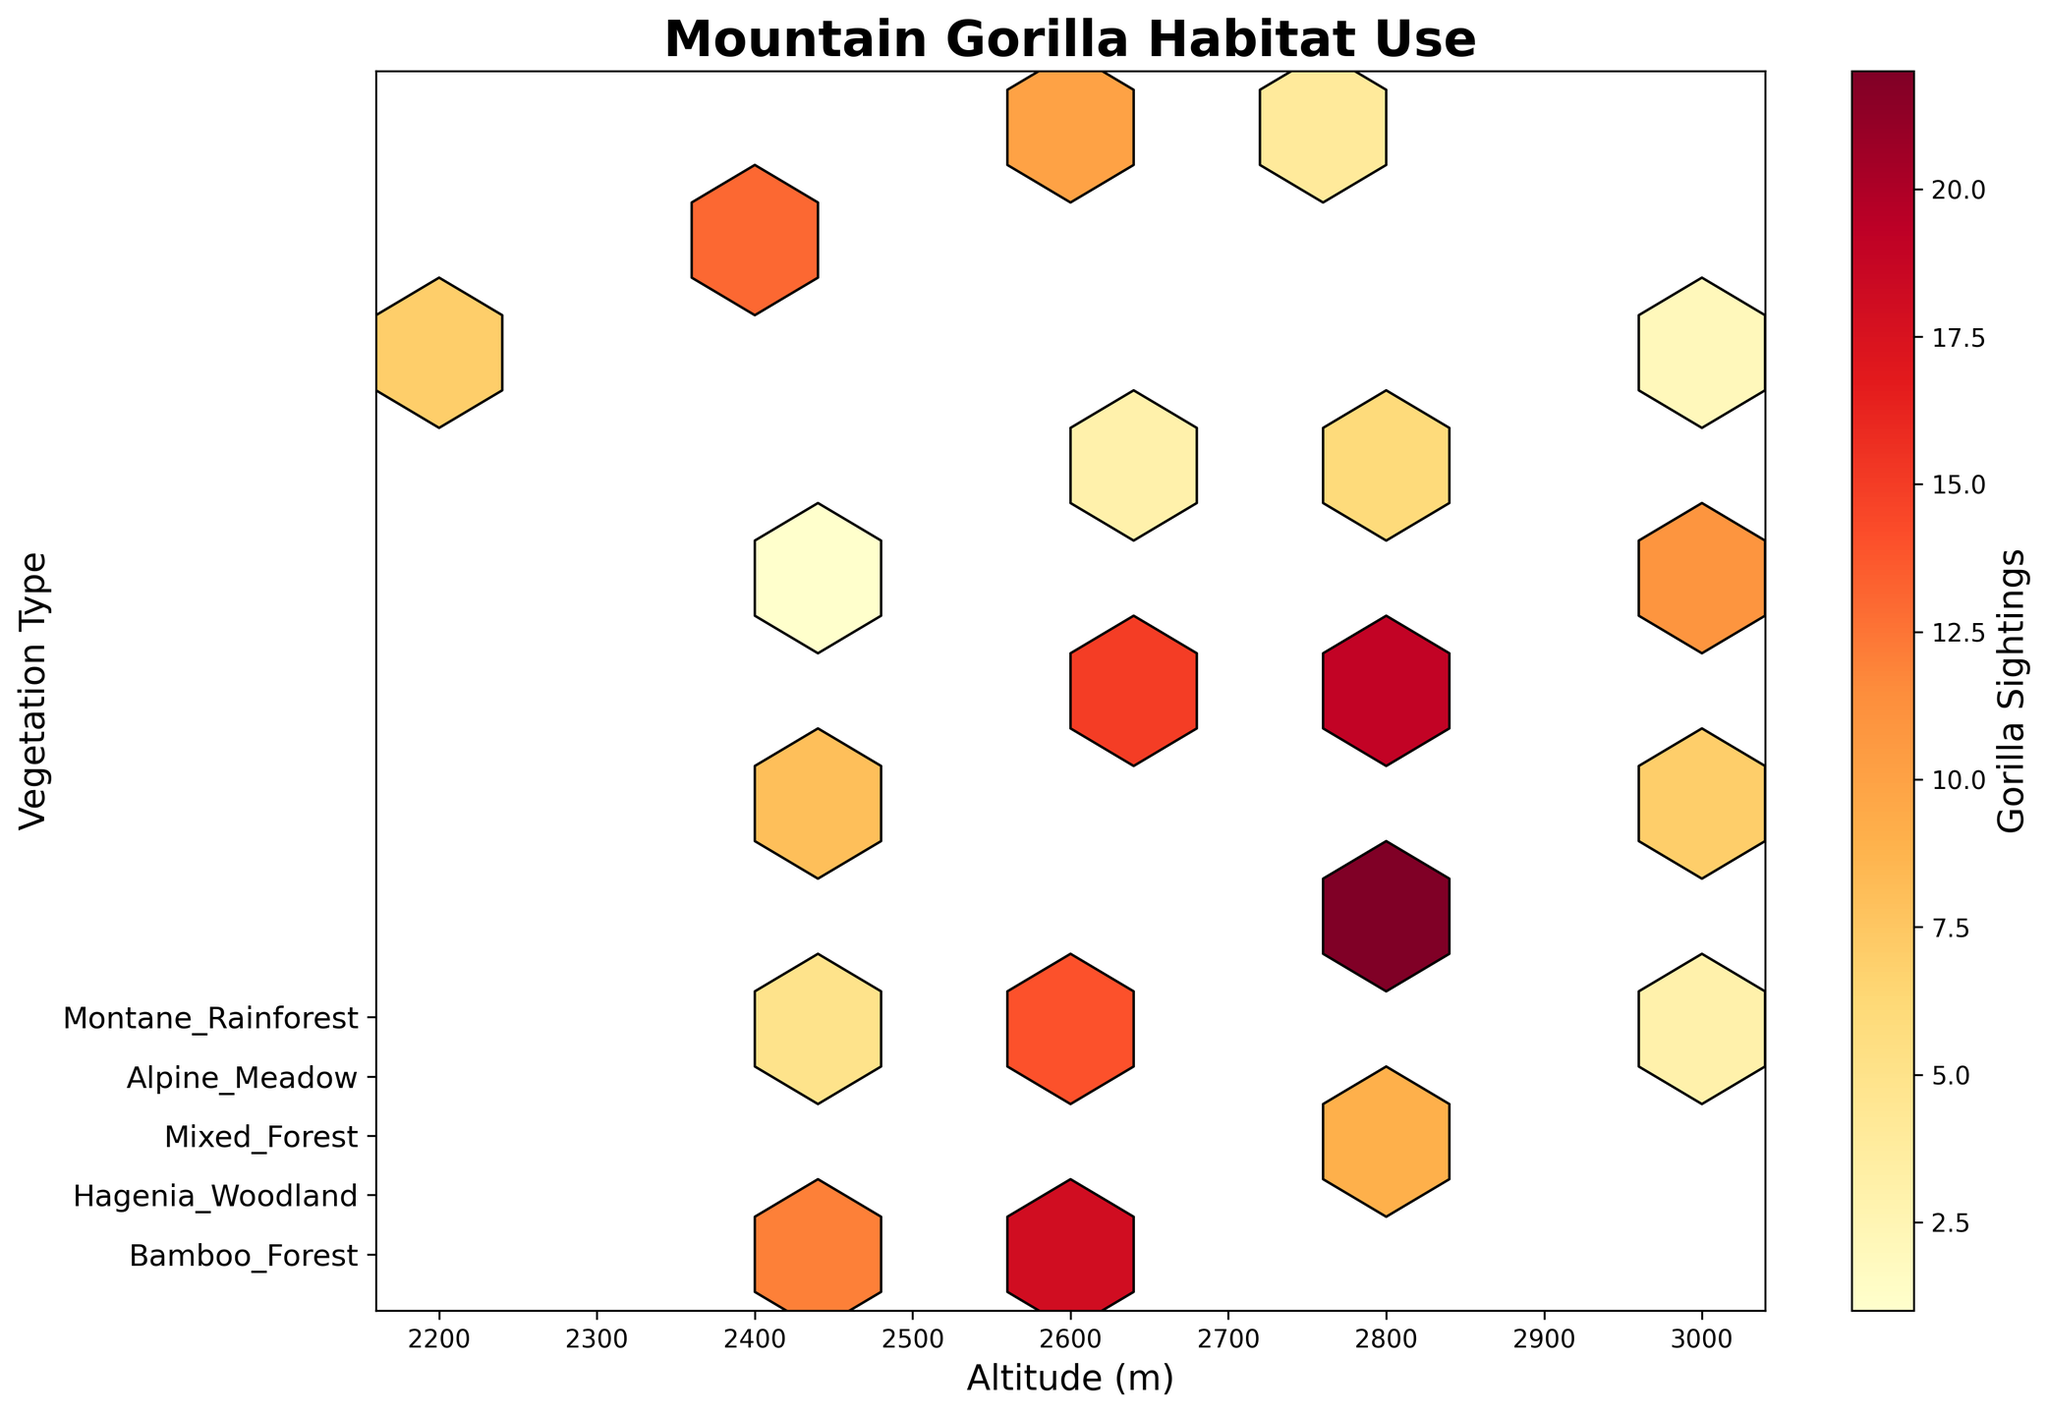What is the title of the plot? The title of the plot is usually found at the top and describes the main topic or subject. In this case, the title is 'Mountain Gorilla Habitat Use' as indicated in the code.
Answer: Mountain Gorilla Habitat Use What does the color intensity in the hexbin plot represent? The color intensity in a hexbin plot usually indicates the count or concentration of data points within a bin. According to the code, the color intensity in this plot represents the number of Gorilla Sightings.
Answer: Number of Gorilla Sightings Which vegetation type has the highest number of gorilla sightings? To determine this, look at the y-axis labels for vegetation types and find which hexbin has the highest color intensity. From the data provided, Bamboo Forest and Hagenia Woodland show high gorilla sightings, but we would look for the exact location on the plot.
Answer: Hagenia Woodland What altitude range shows the most gorilla sightings overall? To find the altitude range with the most sightings, observe the x-axis for altitude and the corresponding color intensity across the altitude bins. Visual cues indicate the peaks in colors.
Answer: 2600-2800 meters How do gorilla sightings in Montane Rainforest compare across different altitudes? Compare the color intensities of hexbin cells along the y-axis corresponding to Montane Rainforest and the x-axis for different altitudes. The sightings in Montane Rainforest appear to be lower at higher altitudes.
Answer: Sightings decrease with altitude Which vegetation type shows a decline in gorilla sightings as altitude increases? By analyzing the hexbin color intensities for each vegetation type along the y-axis as the altitude increases on the x-axis, you can see the trend. Bamboo Forest shows a decline as altitude increases.
Answer: Bamboo Forest Which altitude has the least gorilla sightings in Alpine Meadow? Check for the lowest color intensity within the bins corresponding to Alpine Meadow along the y-axis and compare across altitudes on the x-axis. The plot indicates very low sightings in general for Alpine Meadow, with the least at 2400 meters.
Answer: 2400 meters What can be inferred about gorilla sightings in Hagenia Woodland at 2800 meters? Look at the color intensity for Hagenia Woodland at 2800 meters along the y-axis and x-axis, respectively. High color intensity shows multiple sightings, indicating heavy use of this habitat at that altitude.
Answer: High sightings Do gorilla sightings in Mixed Forest increase or decrease with altitude? Follow the trend in hexbin color for Mixed Forest along the y-axis and various altitudes on the x-axis. The sightings seem relatively stable but show a slight decrease at higher altitudes.
Answer: Slightly decrease What does a higher color intensity represent in terms of gorilla habitat use? Higher color intensity in the hexbin plot translates to a higher number of gorilla sightings, indicating a preferred or frequently used habitat.
Answer: Preferred habitat 